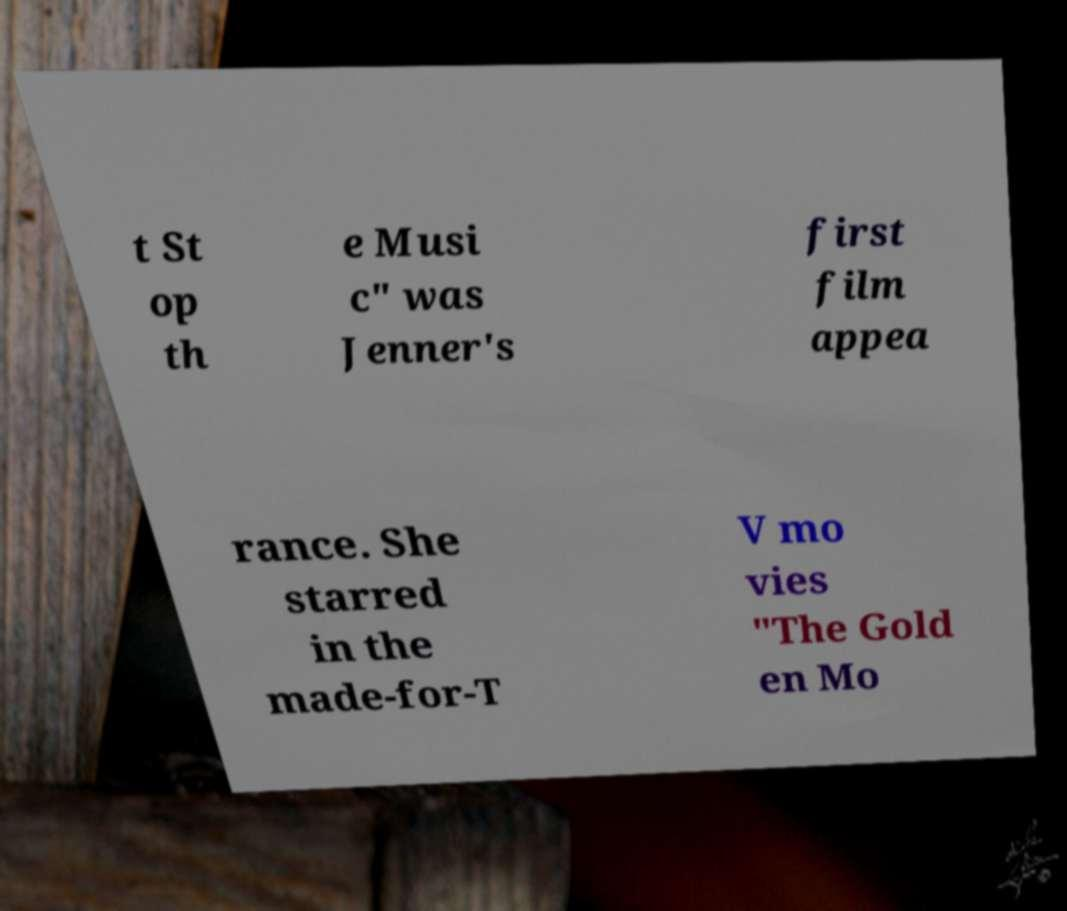Can you read and provide the text displayed in the image?This photo seems to have some interesting text. Can you extract and type it out for me? t St op th e Musi c" was Jenner's first film appea rance. She starred in the made-for-T V mo vies "The Gold en Mo 